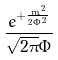<formula> <loc_0><loc_0><loc_500><loc_500>\frac { e ^ { + \frac { m ^ { 2 } } { 2 \Phi ^ { 2 } } } } { \sqrt { 2 \pi } \Phi }</formula> 